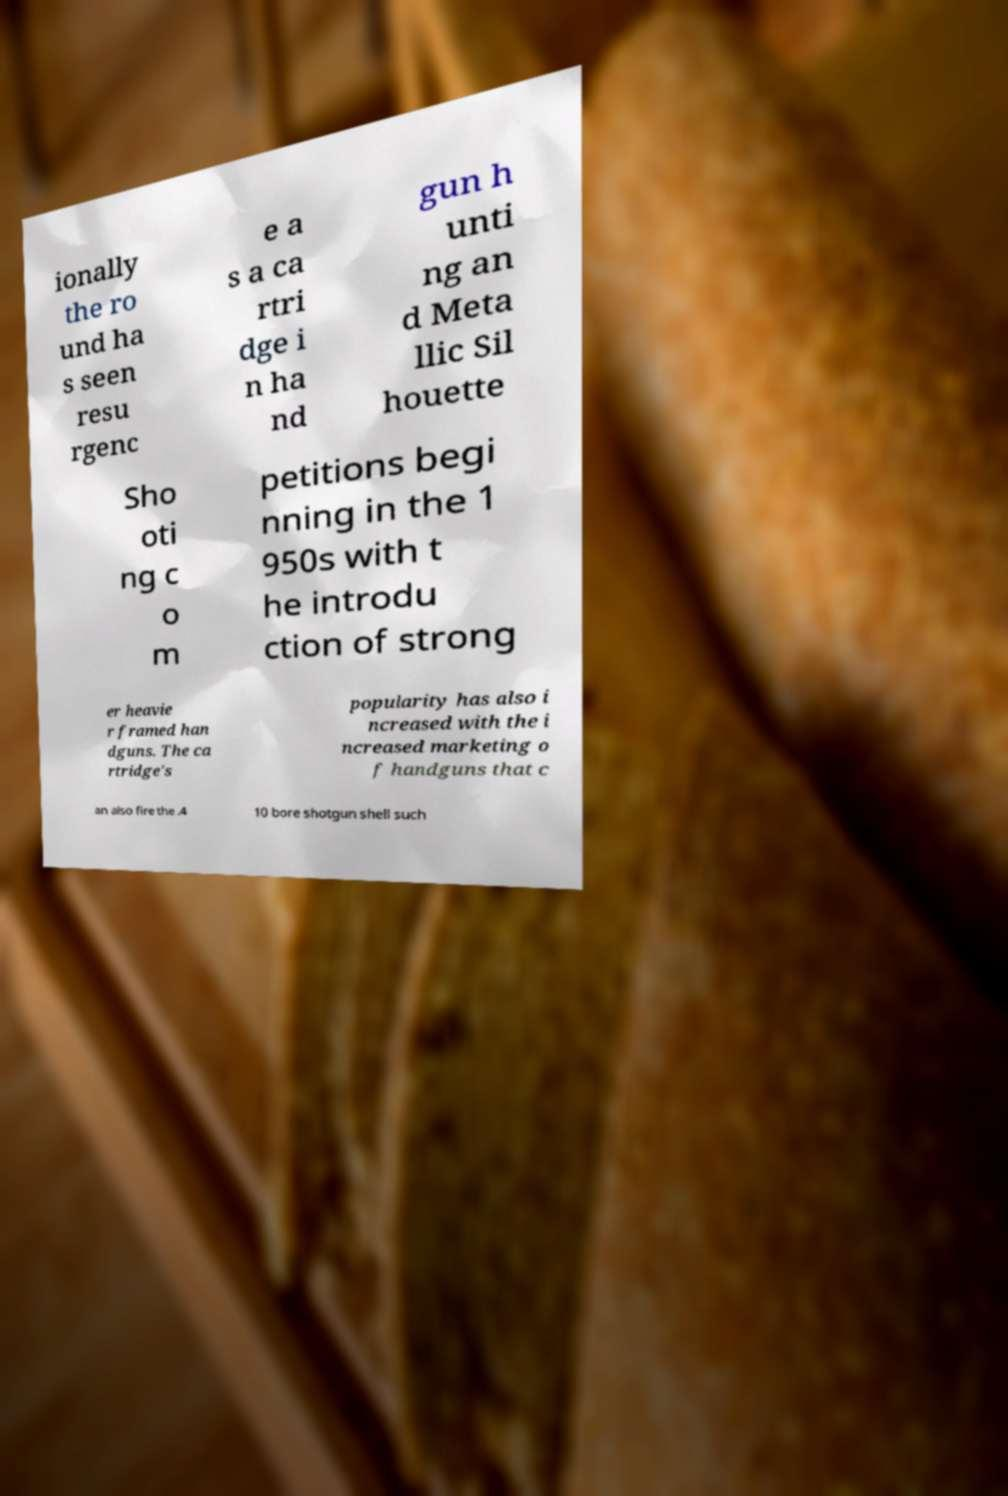Could you assist in decoding the text presented in this image and type it out clearly? ionally the ro und ha s seen resu rgenc e a s a ca rtri dge i n ha nd gun h unti ng an d Meta llic Sil houette Sho oti ng c o m petitions begi nning in the 1 950s with t he introdu ction of strong er heavie r framed han dguns. The ca rtridge's popularity has also i ncreased with the i ncreased marketing o f handguns that c an also fire the .4 10 bore shotgun shell such 